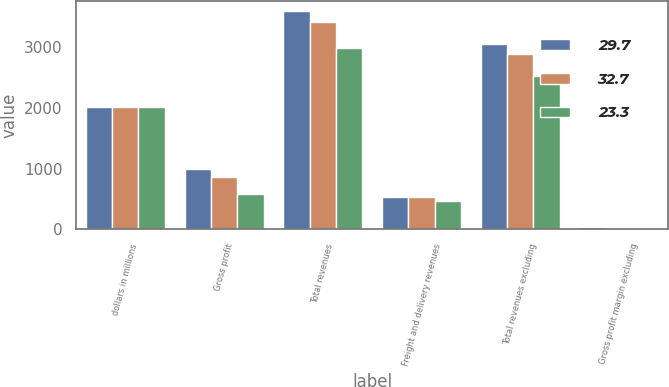Convert chart. <chart><loc_0><loc_0><loc_500><loc_500><stacked_bar_chart><ecel><fcel>dollars in millions<fcel>Gross profit<fcel>Total revenues<fcel>Freight and delivery revenues<fcel>Total revenues excluding<fcel>Gross profit margin excluding<nl><fcel>29.7<fcel>2016<fcel>1000.8<fcel>3592.7<fcel>536<fcel>3056.7<fcel>32.7<nl><fcel>32.7<fcel>2015<fcel>857.5<fcel>3422.2<fcel>538.1<fcel>2884.1<fcel>29.7<nl><fcel>23.3<fcel>2014<fcel>587.6<fcel>2994.2<fcel>473.1<fcel>2521.1<fcel>23.3<nl></chart> 